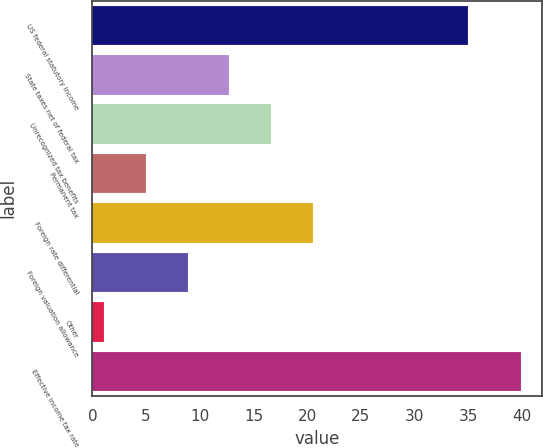Convert chart. <chart><loc_0><loc_0><loc_500><loc_500><bar_chart><fcel>US federal statutory income<fcel>State taxes net of federal tax<fcel>Unrecognized tax benefits<fcel>Permanent tax<fcel>Foreign rate differential<fcel>Foreign valuation allowance<fcel>Other<fcel>Effective income tax rate<nl><fcel>35<fcel>12.74<fcel>16.62<fcel>4.98<fcel>20.5<fcel>8.86<fcel>1.1<fcel>39.9<nl></chart> 